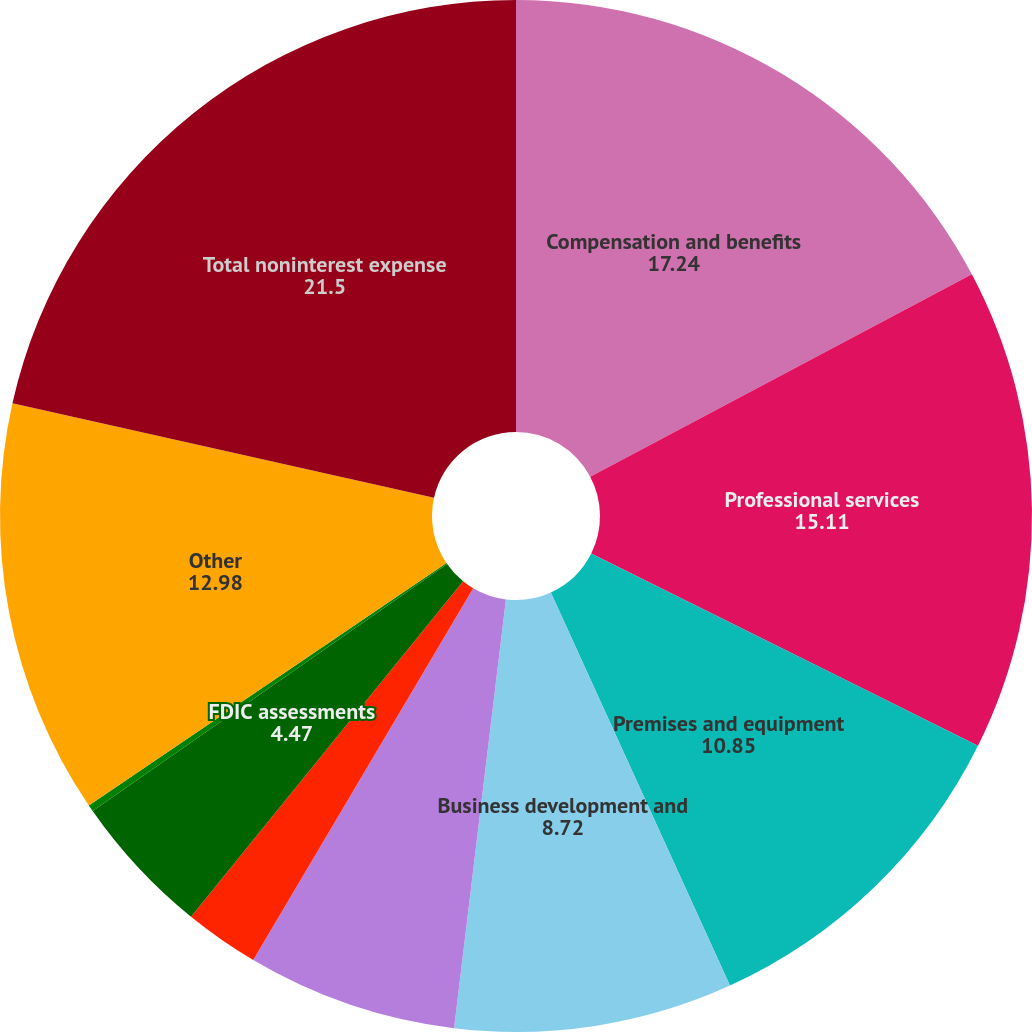Convert chart to OTSL. <chart><loc_0><loc_0><loc_500><loc_500><pie_chart><fcel>Compensation and benefits<fcel>Professional services<fcel>Premises and equipment<fcel>Business development and<fcel>Net occupancy<fcel>Correspondent bank fees<fcel>FDIC assessments<fcel>Provision for unfunded credit<fcel>Other<fcel>Total noninterest expense<nl><fcel>17.24%<fcel>15.11%<fcel>10.85%<fcel>8.72%<fcel>6.59%<fcel>2.34%<fcel>4.47%<fcel>0.21%<fcel>12.98%<fcel>21.5%<nl></chart> 